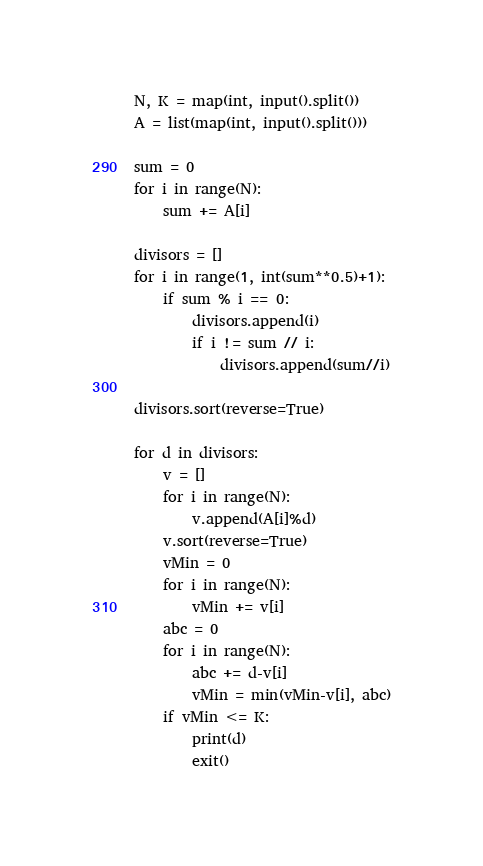<code> <loc_0><loc_0><loc_500><loc_500><_Python_>N, K = map(int, input().split())
A = list(map(int, input().split()))

sum = 0
for i in range(N):
    sum += A[i]

divisors = []
for i in range(1, int(sum**0.5)+1):
    if sum % i == 0:
        divisors.append(i)
        if i != sum // i:
            divisors.append(sum//i)

divisors.sort(reverse=True)

for d in divisors:
    v = []
    for i in range(N):
        v.append(A[i]%d)
    v.sort(reverse=True)
    vMin = 0
    for i in range(N):
        vMin += v[i]
    abc = 0
    for i in range(N):
        abc += d-v[i]
        vMin = min(vMin-v[i], abc)
    if vMin <= K:
        print(d)
        exit()
</code> 